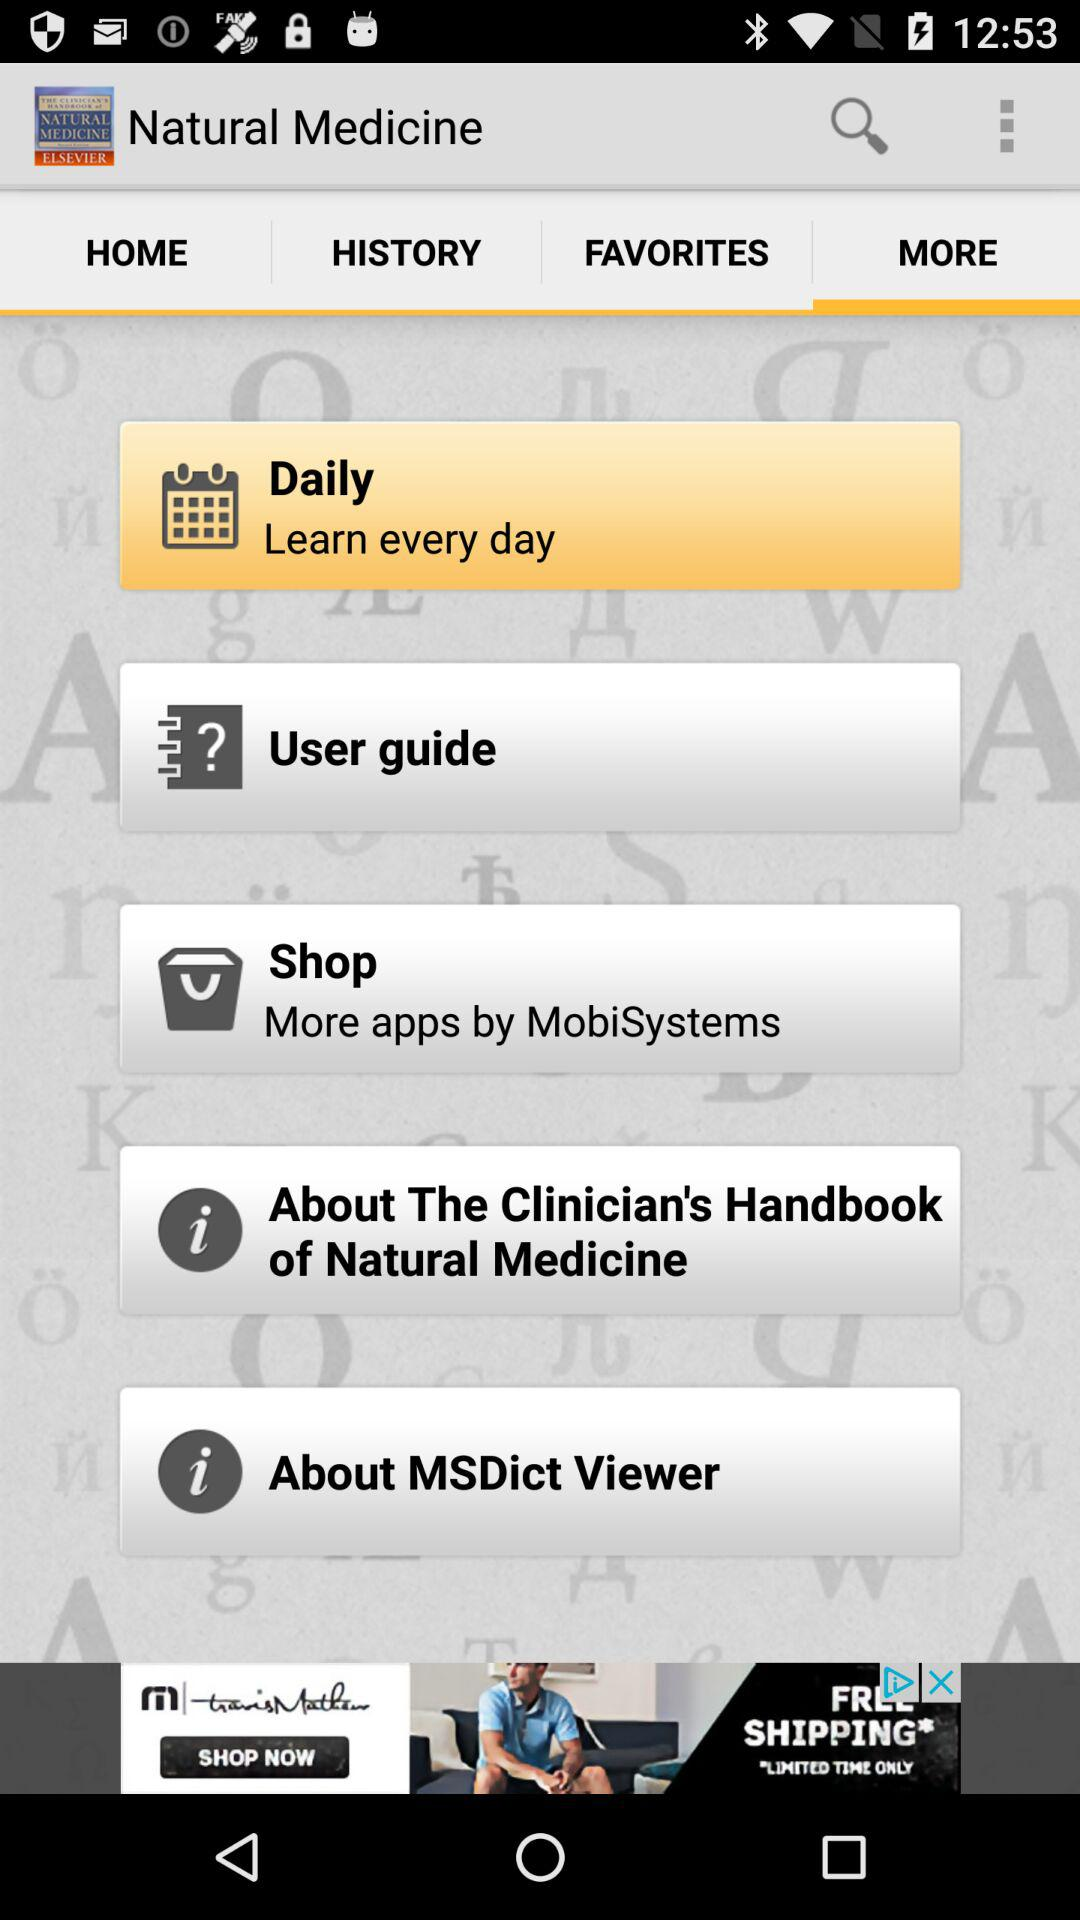What is the name of the application? The name of the application is "Natural Medicine". 